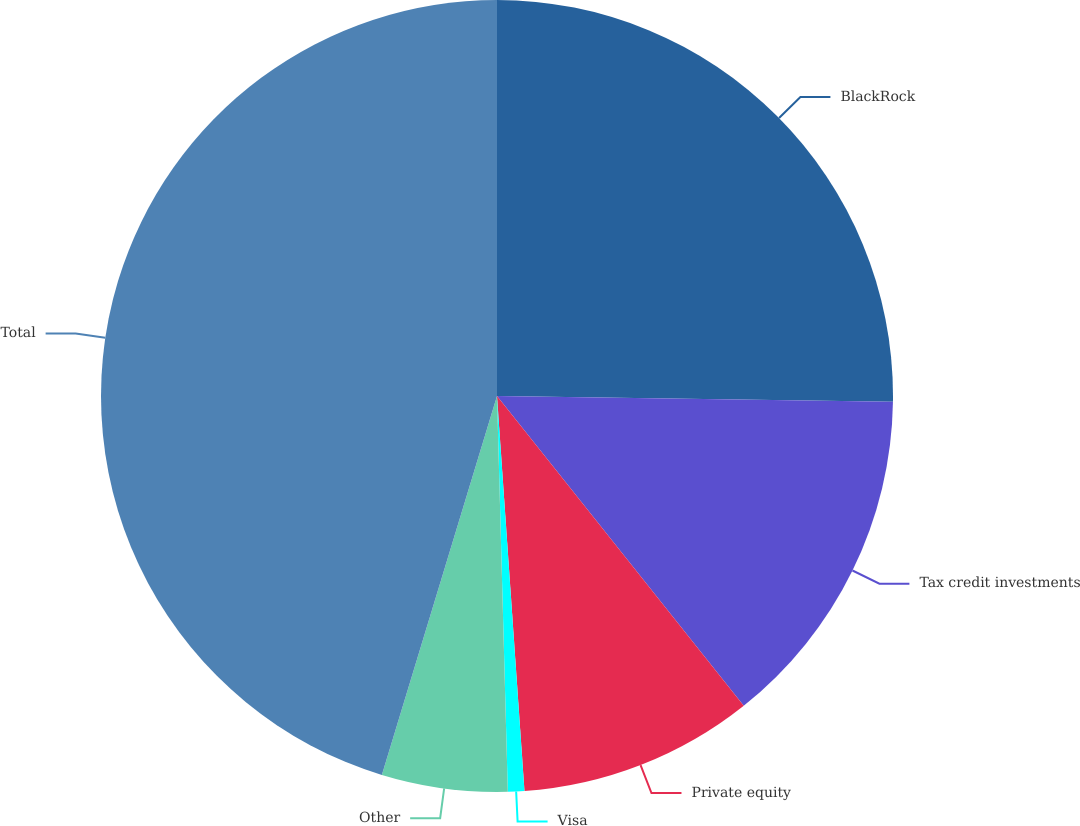Convert chart to OTSL. <chart><loc_0><loc_0><loc_500><loc_500><pie_chart><fcel>BlackRock<fcel>Tax credit investments<fcel>Private equity<fcel>Visa<fcel>Other<fcel>Total<nl><fcel>25.23%<fcel>14.06%<fcel>9.6%<fcel>0.67%<fcel>5.13%<fcel>45.3%<nl></chart> 